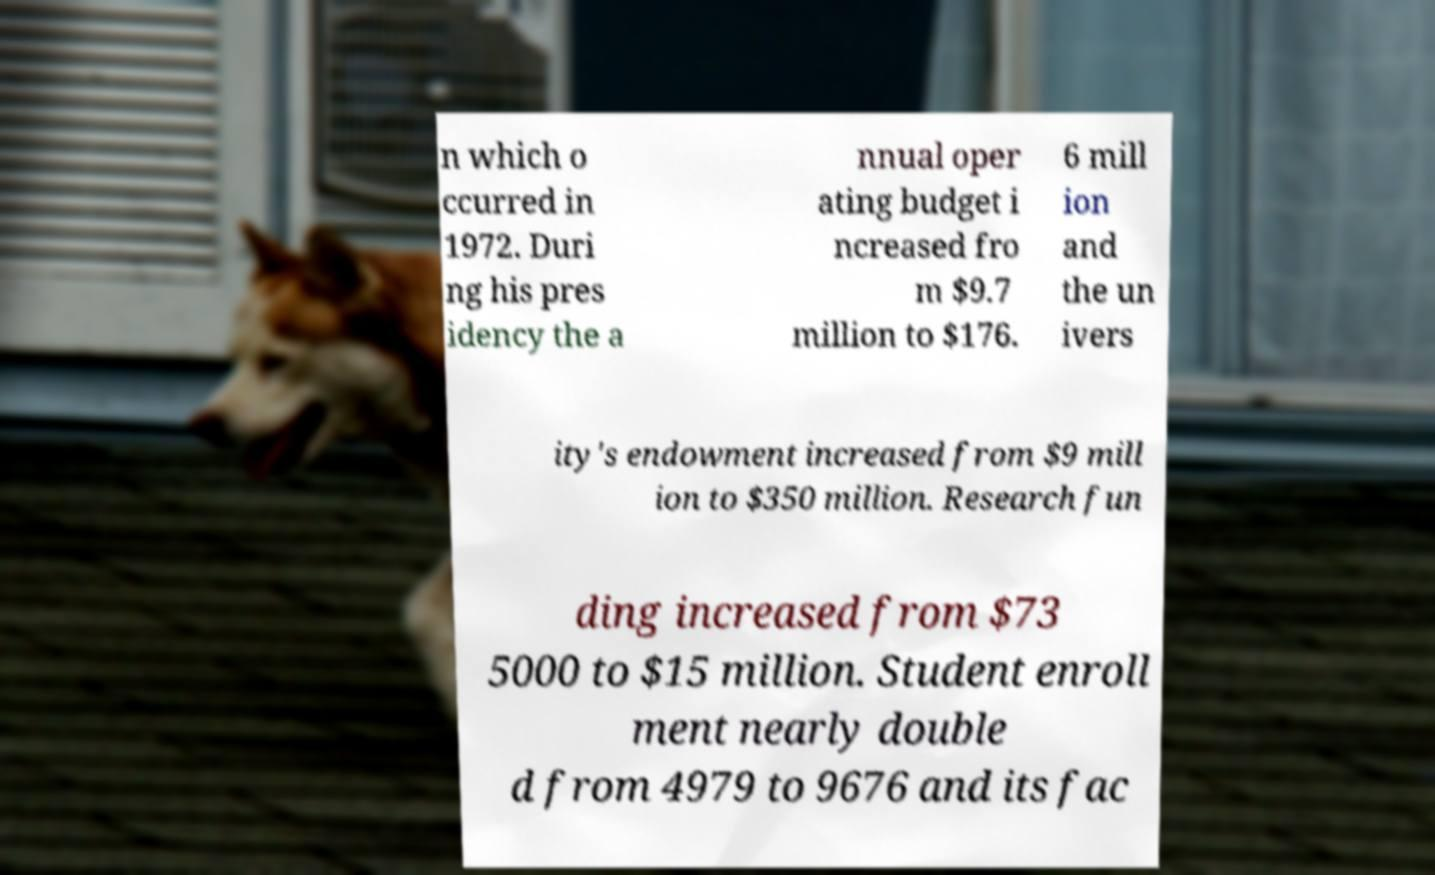I need the written content from this picture converted into text. Can you do that? n which o ccurred in 1972. Duri ng his pres idency the a nnual oper ating budget i ncreased fro m $9.7 million to $176. 6 mill ion and the un ivers ity's endowment increased from $9 mill ion to $350 million. Research fun ding increased from $73 5000 to $15 million. Student enroll ment nearly double d from 4979 to 9676 and its fac 